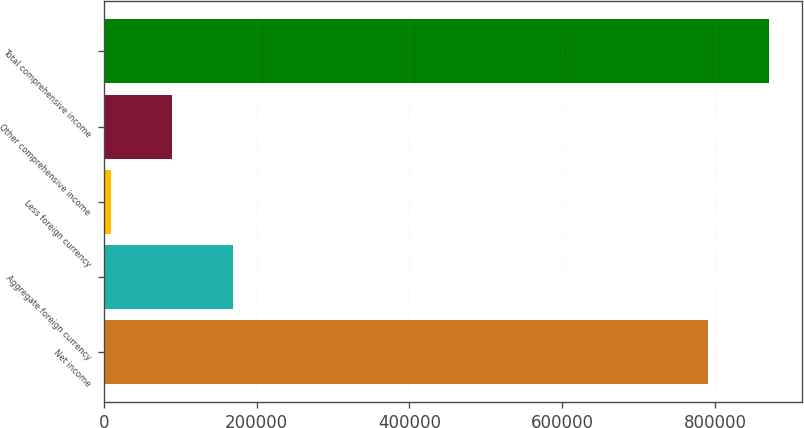Convert chart to OTSL. <chart><loc_0><loc_0><loc_500><loc_500><bar_chart><fcel>Net income<fcel>Aggregate foreign currency<fcel>Less foreign currency<fcel>Other comprehensive income<fcel>Total comprehensive income<nl><fcel>790456<fcel>169207<fcel>9662<fcel>89434.3<fcel>870228<nl></chart> 